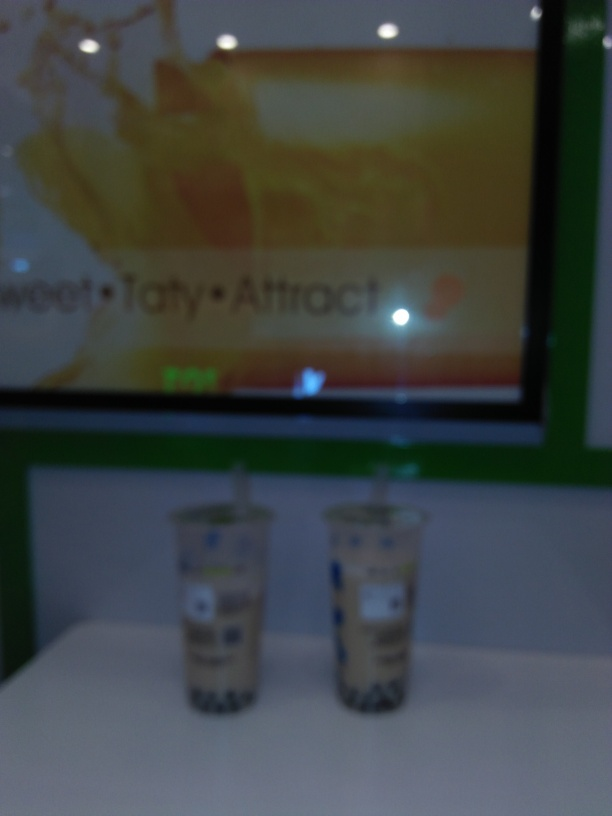How would you describe the lighting condition in the image? The lighting in the image is bright and most likely artificial, as indicated by the reflections and glare on the countertop and the glossy finish of the advertisement in the background. 